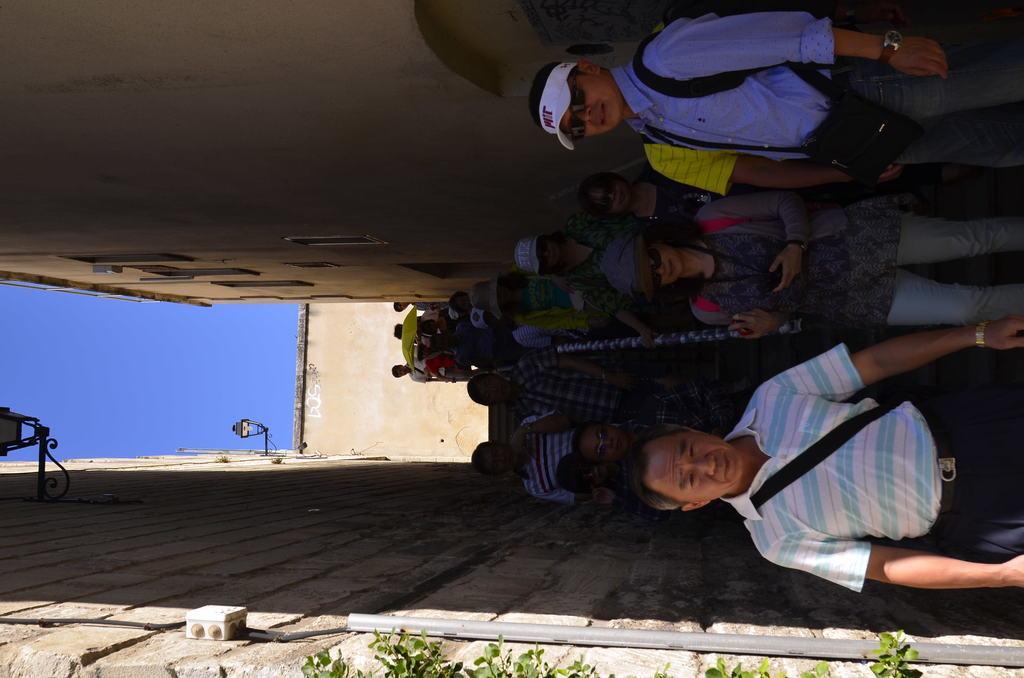Can you describe this image briefly? This is a tilted picture. In this picture we can see the wall, skylights, green leaves and few objects. In this picture we can see the people, stairs and a rod. 